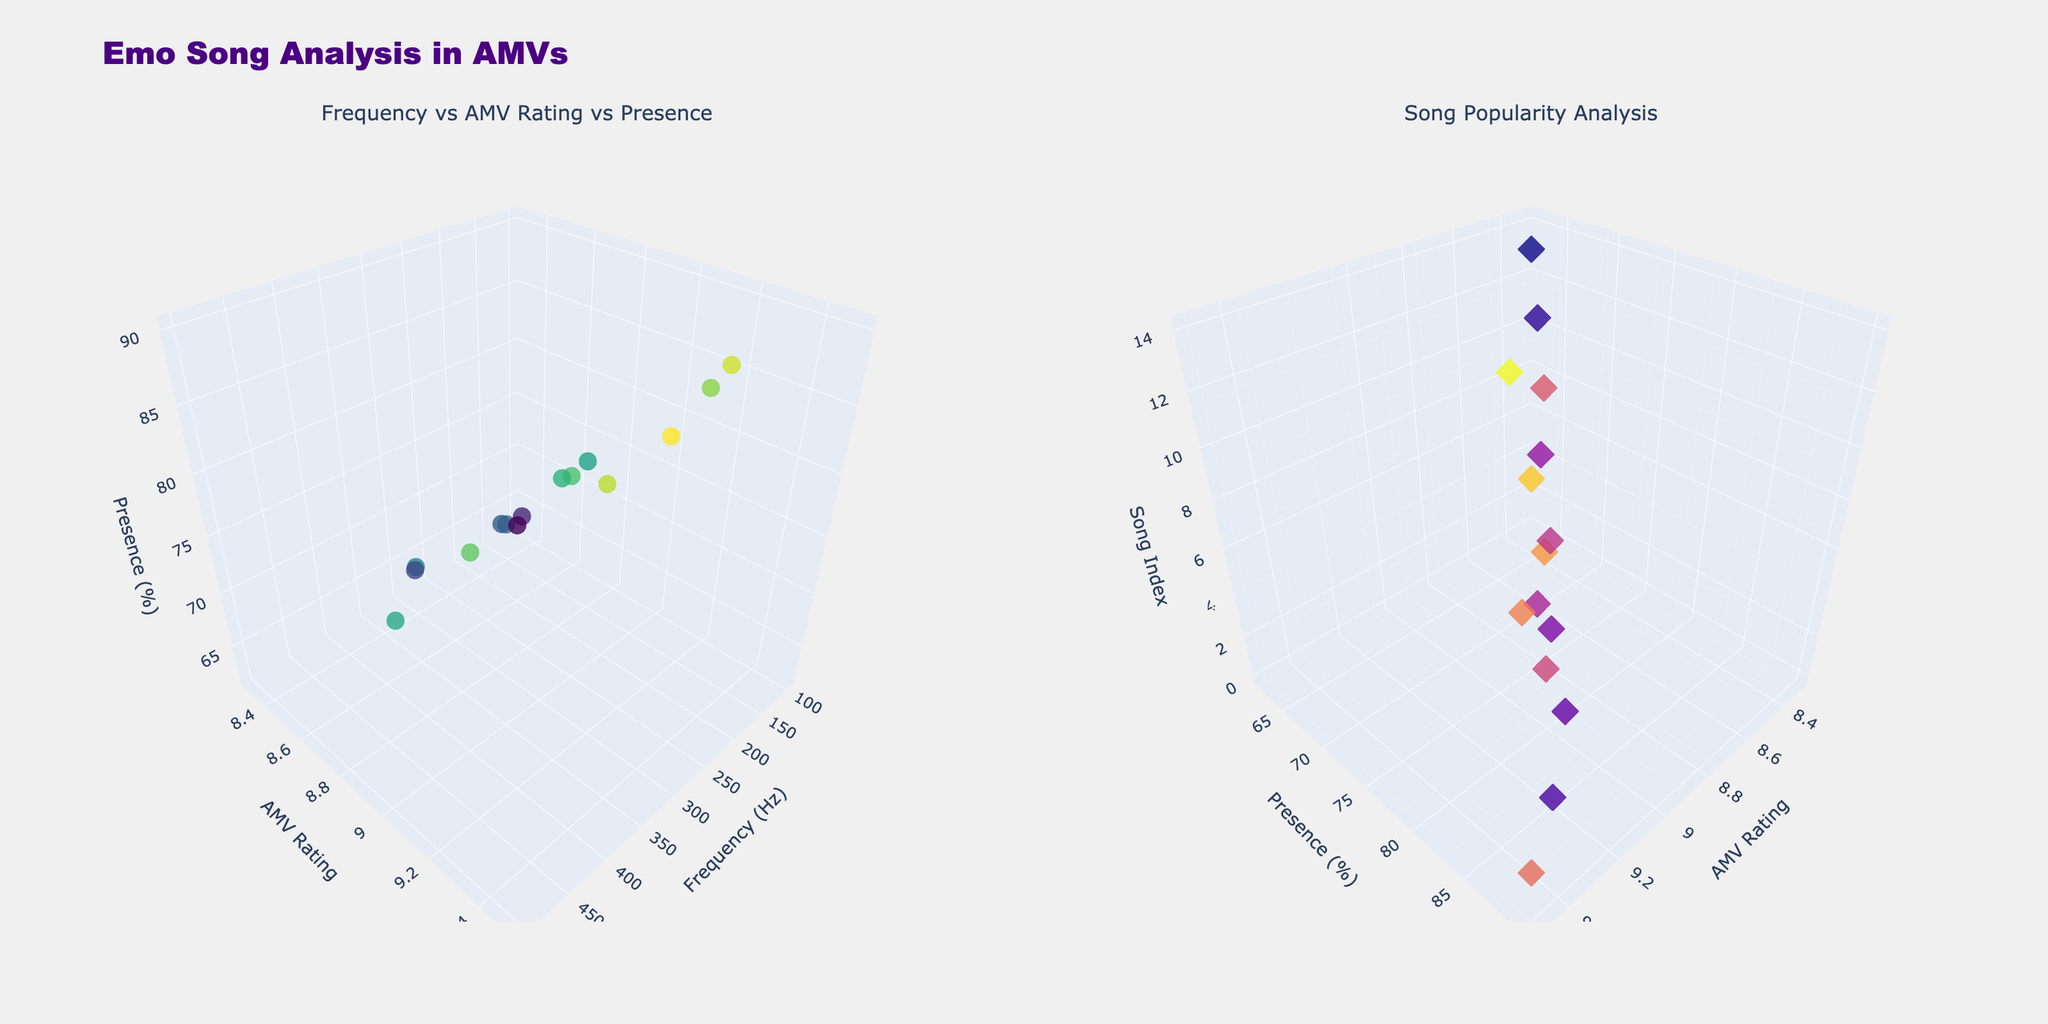What is the title of the figure? The title is included in the layout of the plot and says "Emo Song Analysis in AMVs".
Answer: Emo Song Analysis in AMVs Which song has the highest frequency in the first subplot? The 3D scatter plot uses colors to represent "Presence (%)" with "Frequency (Hz)" on the x-axis, "AMV Rating" on the y-axis, and "Presence (%)" on the z-axis. The highest "Frequency (Hz)" in the data is 500 Hz, which corresponds to the song "Dance Dance".
Answer: Dance Dance Which song has the lowest AMV rating in the second subplot? The second 3D scatter plot uses colors to represent "Frequency (Hz)" with "AMV Rating" on the x-axis, "Presence (%)" on the y-axis, and the song index on the z-axis. The lowest "AMV Rating" in the data is 8.3, which corresponds to the song "Incomplete".
Answer: Incomplete How many data points are there in total? The figure contains 3D scatter plots with one data point for each song listed in the data. There are 15 songs in the dataset.
Answer: 15 What is the range of 'Presence (%)' for the songs in the first subplot? In the first subplot, the z-axis represents "Presence (%)". The data shows the range from 62% to 90%.
Answer: 62% to 90% Which song has both high frequency and high AMV rating based on the first subplot? In the first subplot, "Frequency (Hz)" is on the x-axis and "AMV Rating" is on the y-axis. The song with both high frequency (350 Hz, which is close to the max frequency) and high AMV rating (9.5) is "Misery Business".
Answer: Misery Business Is there a correlation between frequency and AMV rating in the figure? The first subplot shows scatter points of "Frequency (Hz)" versus "AMV Rating". The data points appear randomly distributed without a clear upward or downward trend, indicating no strong correlation.
Answer: No strong correlation Which song appears closer to the origin in the second subplot? In the second subplot, the origin is where "AMV Rating", "Presence (%)", and the song index are all at their minimum. The song "Incomplete" has an "AMV Rating" of 8.3 and a "Presence (%)" of 62%, both of which are among the lowest in the dataset, placing it closest to the plot origin.
Answer: Incomplete Which subplot uses the 'Plasma' color scale? The second subplot distinguishes itself using a 'Plasma' color scale for "Frequency (Hz)", while the first subplot uses a 'Viridis' color scale.
Answer: Second subplot Which song has the highest presence in AMVs based on both subplots? In both subplots, "Presence (%)" is used. The song with the highest presence at 90% is "Misery Business".
Answer: Misery Business 